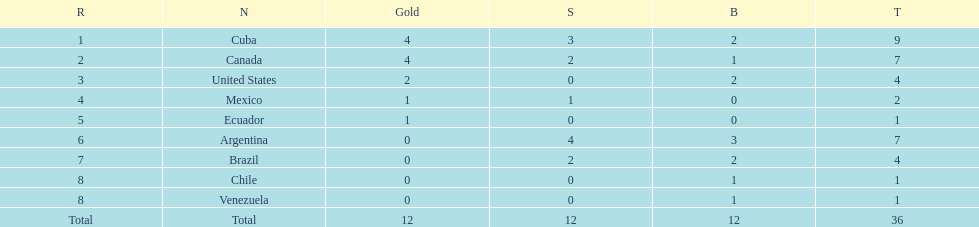How many medals has argentina secured in total? 7. 